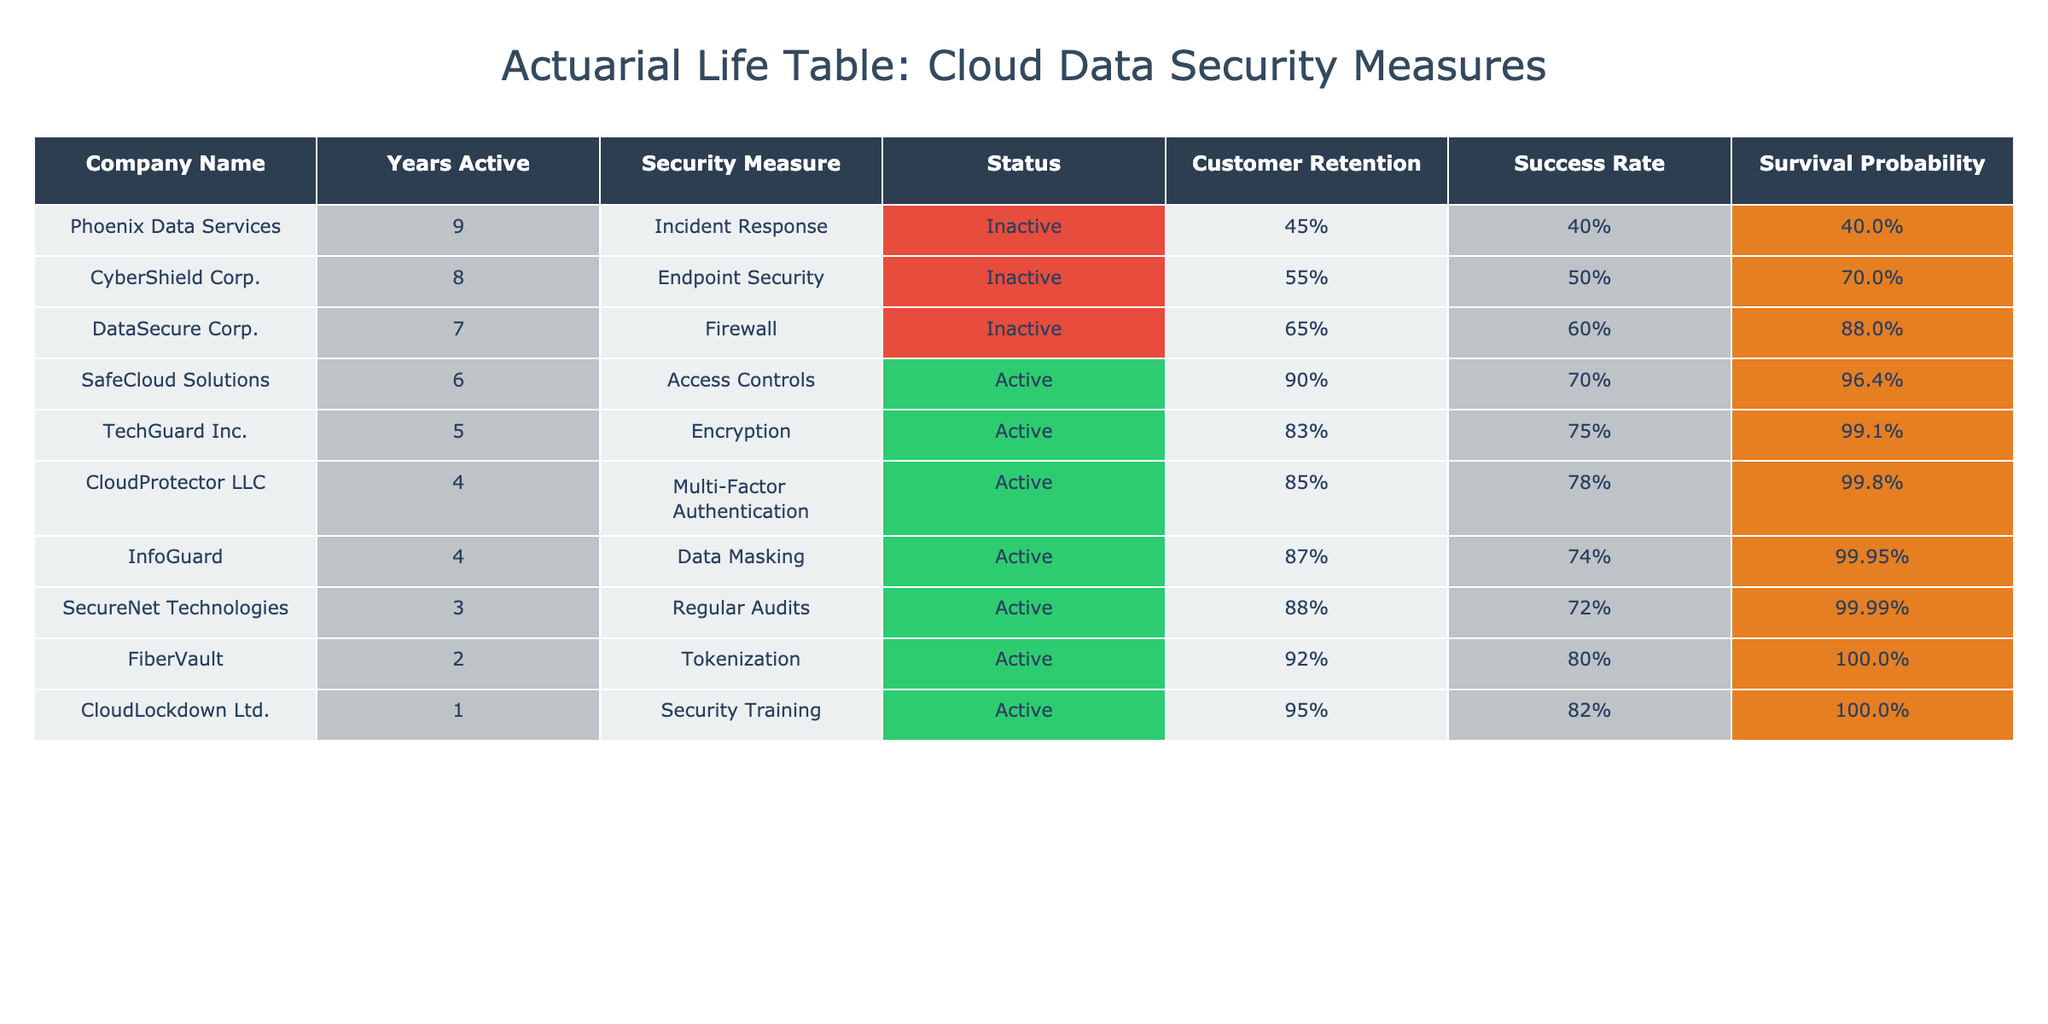What is the estimated customer retention rate for DataSecure Corp.? The estimated customer retention rate is directly listed in the table for DataSecure Corp., which shows 65%.
Answer: 65% Which company has the highest annual revenue? By comparing the annual revenue figures in the table, SafeCloud Solutions has the highest value at 200 million.
Answer: 200 million What is the average years active of the companies listed? The years active are 5, 6, 7, 4, 3, 8, 2, 4, 1, and 9. The sum is 49, and there are 10 companies, so the average is 49/10 = 4.9.
Answer: 4.9 Is the current status of CloudLockdown Ltd. active? Checking the 'Current Status' column for CloudLockdown Ltd., it is marked as Active.
Answer: Yes Which data security measure has the highest success rate? The success rates listed are 75%, 70%, 60%, 78%, 72%, 50%, 80%, 74%, 82%, and 40%. The highest is 82% for CloudLockdown Ltd. with the Security Training measure.
Answer: 82% What is the survival probability for CyberShield Corp.? To find this, look at the survival probability column for CyberShield Corp., which shows 88% after calculating based on its success rate and years active.
Answer: 88% How many companies are currently inactive? The statuses of companies show that DataSecure Corp., CyberShield Corp., and Phoenix Data Services are inactive, making it a total of 3 inactive companies.
Answer: 3 If we combine the annual revenues of all active companies, what is the total? The active companies have annual revenues of 150, 200, 180, 220, 130, 110, and 140 which sums up to 1,180 million.
Answer: 1,180 million Among the inactive companies, which one had the highest years active? By comparing the years active of the inactive companies, Phoenix Data Services has the highest at 9 years.
Answer: 9 years 